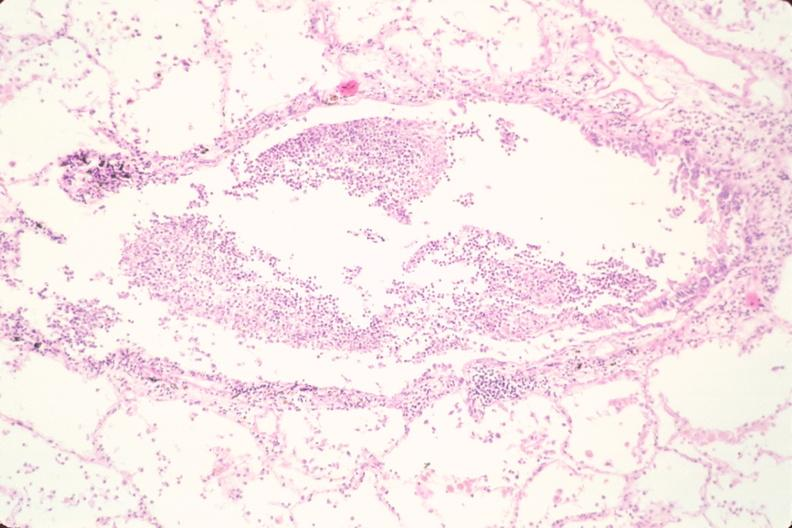does this image show lung, bronchopneumonia, bacterial?
Answer the question using a single word or phrase. Yes 